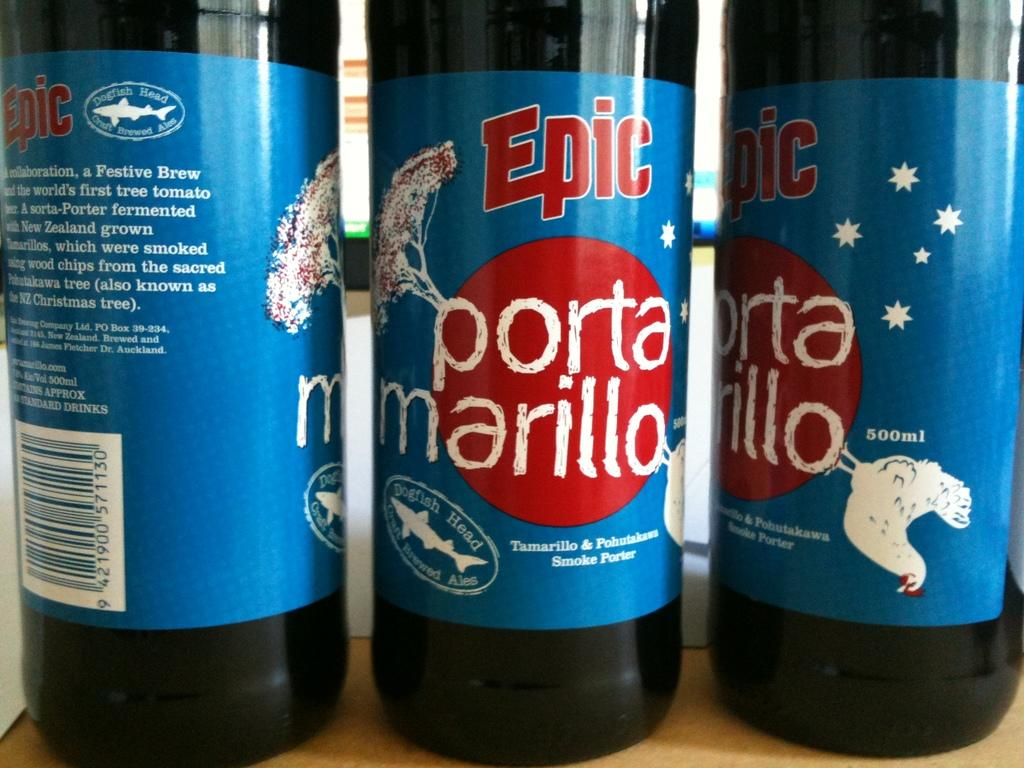<image>
Describe the image concisely. Three bottles of Epic porta marillo are lined up on a table. 